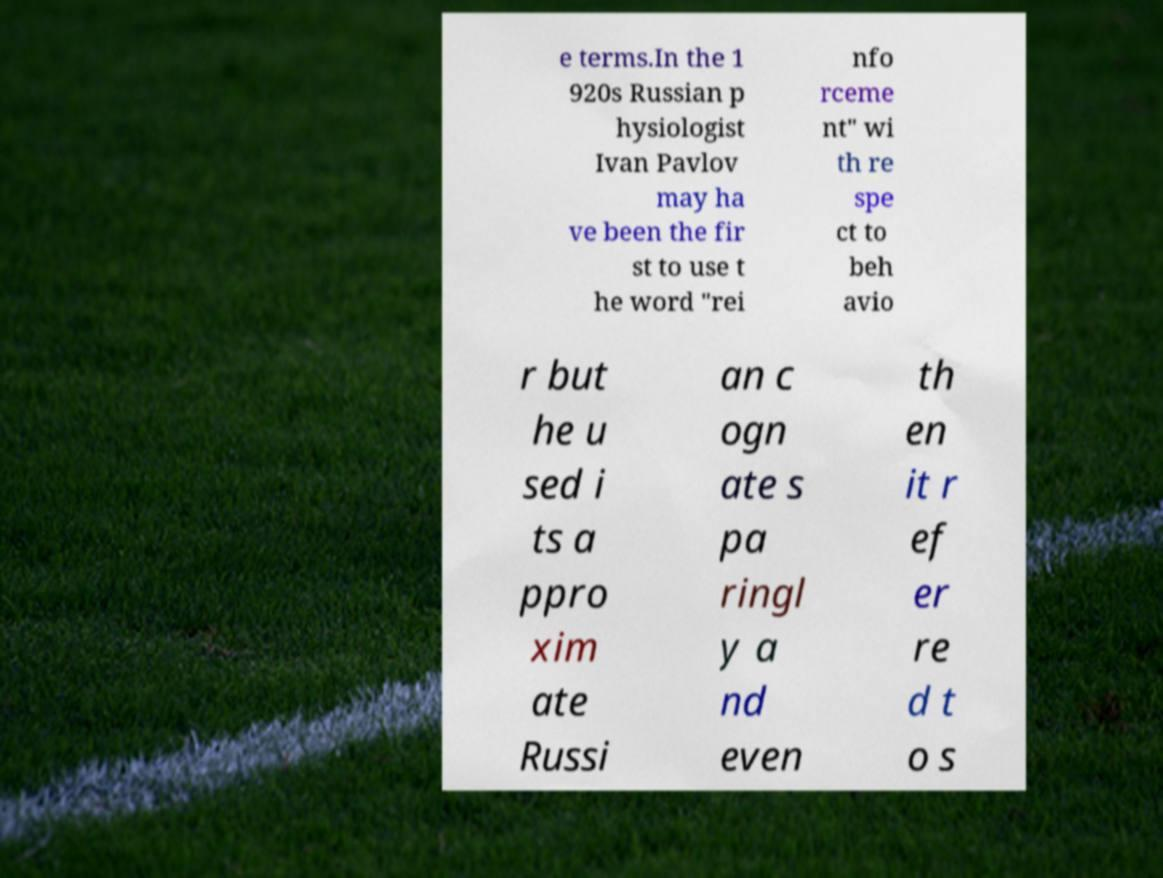Can you accurately transcribe the text from the provided image for me? e terms.In the 1 920s Russian p hysiologist Ivan Pavlov may ha ve been the fir st to use t he word "rei nfo rceme nt" wi th re spe ct to beh avio r but he u sed i ts a ppro xim ate Russi an c ogn ate s pa ringl y a nd even th en it r ef er re d t o s 